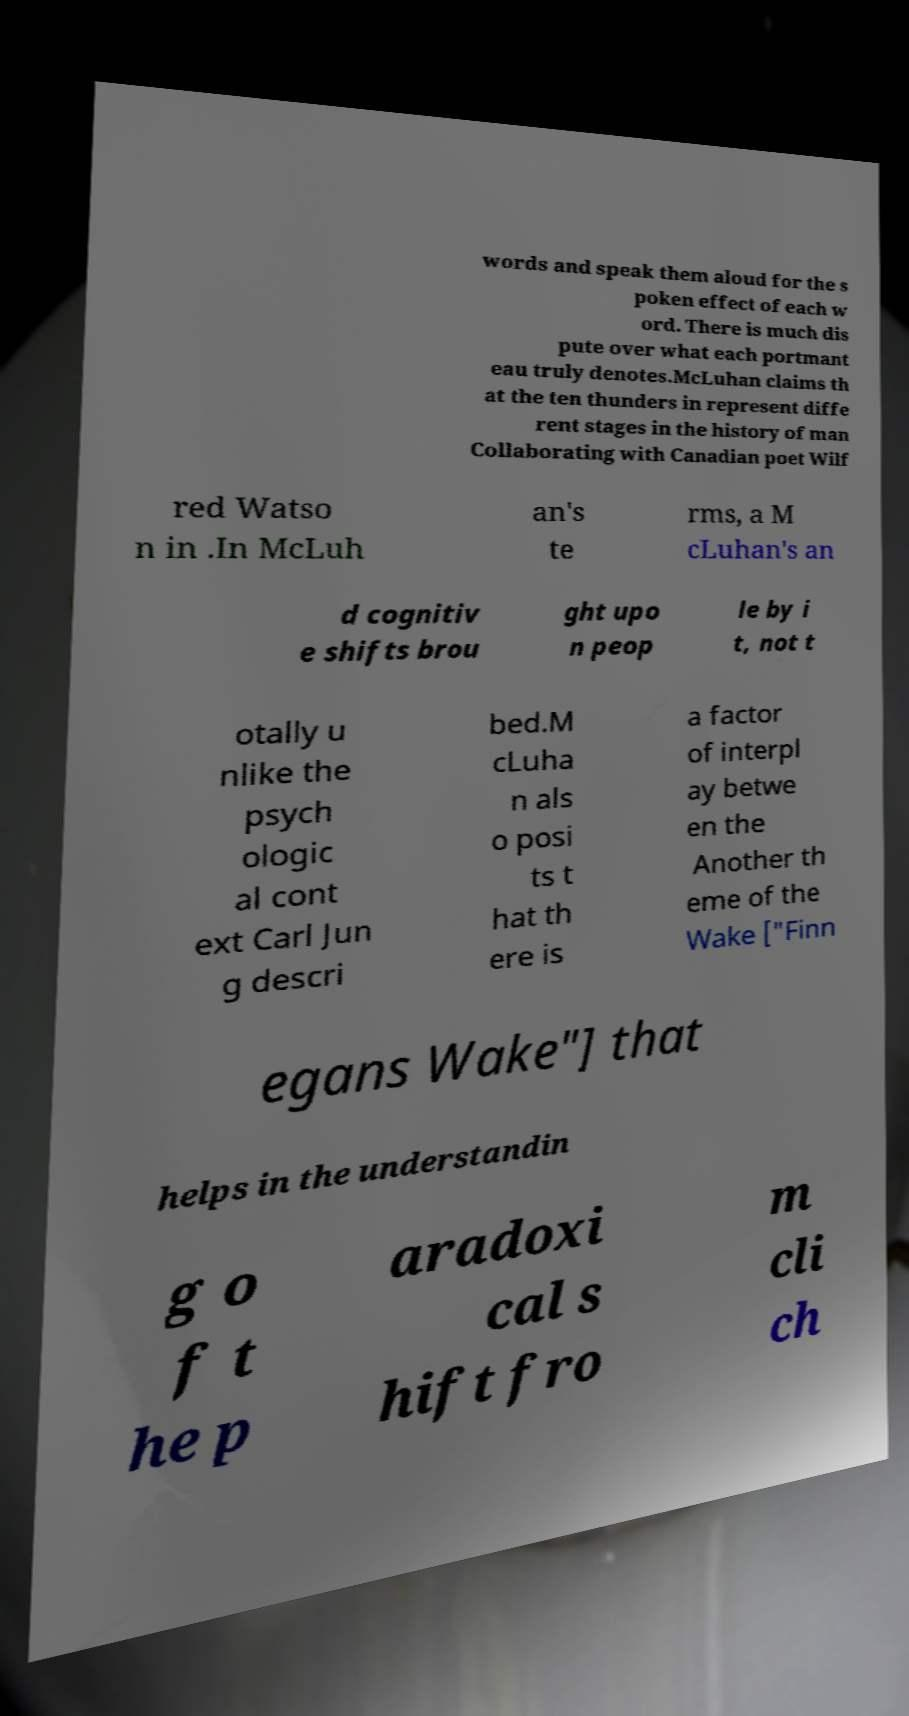There's text embedded in this image that I need extracted. Can you transcribe it verbatim? words and speak them aloud for the s poken effect of each w ord. There is much dis pute over what each portmant eau truly denotes.McLuhan claims th at the ten thunders in represent diffe rent stages in the history of man Collaborating with Canadian poet Wilf red Watso n in .In McLuh an's te rms, a M cLuhan's an d cognitiv e shifts brou ght upo n peop le by i t, not t otally u nlike the psych ologic al cont ext Carl Jun g descri bed.M cLuha n als o posi ts t hat th ere is a factor of interpl ay betwe en the Another th eme of the Wake ["Finn egans Wake"] that helps in the understandin g o f t he p aradoxi cal s hift fro m cli ch 